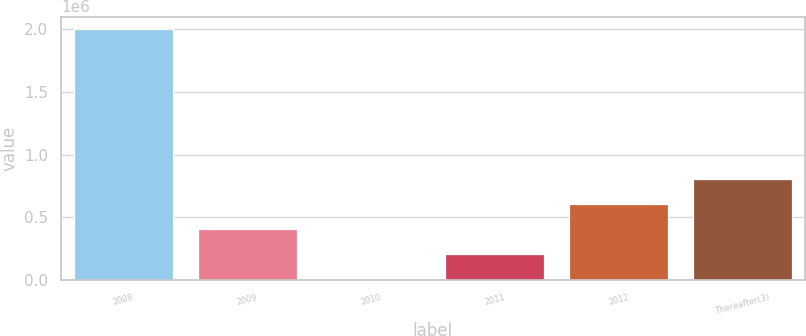Convert chart to OTSL. <chart><loc_0><loc_0><loc_500><loc_500><bar_chart><fcel>2008<fcel>2009<fcel>2010<fcel>2011<fcel>2012<fcel>Thereafter(3)<nl><fcel>2.00226e+06<fcel>402654<fcel>2752<fcel>202703<fcel>602605<fcel>802556<nl></chart> 